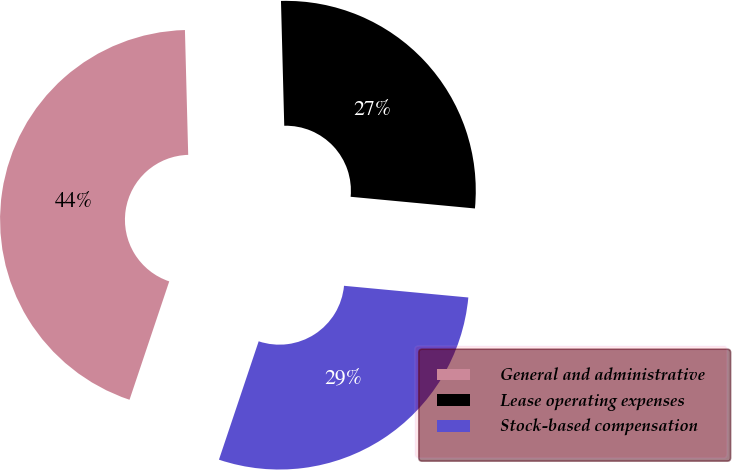<chart> <loc_0><loc_0><loc_500><loc_500><pie_chart><fcel>General and administrative<fcel>Lease operating expenses<fcel>Stock-based compensation<nl><fcel>44.43%<fcel>26.91%<fcel>28.66%<nl></chart> 